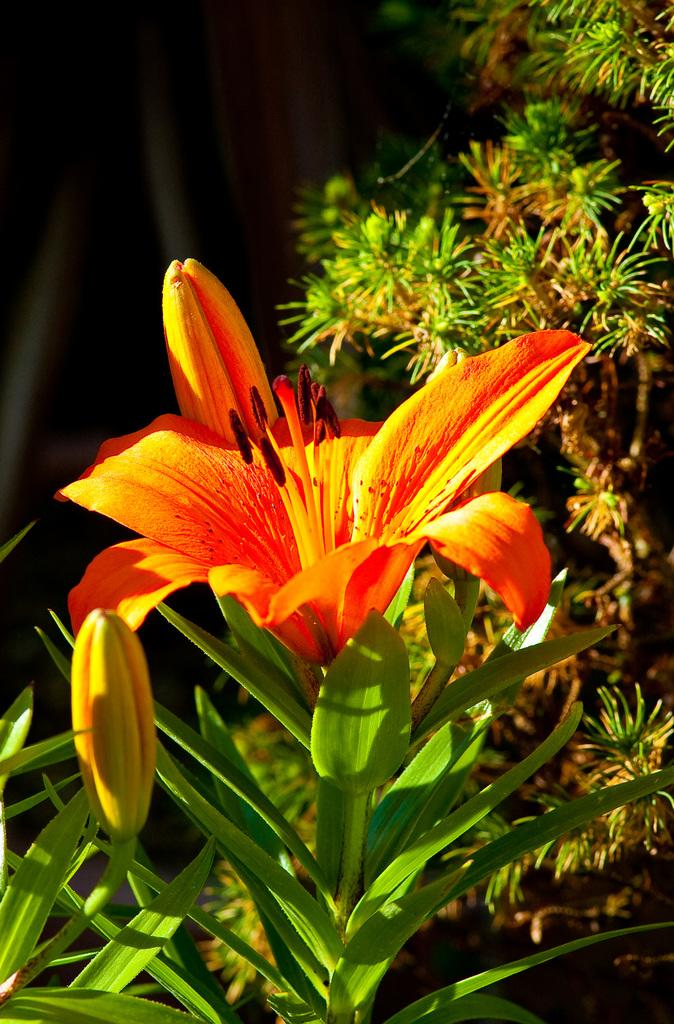What type of plant is featured in the image? There is a flower in the image. What stage of growth are the buds on the plant in? The buds on the plant are not yet fully bloomed. Are there any other plants visible in the image? Yes, there are other plants visible in the image. What is the color of the background in the image? The background of the image is dark. Can you see a scarecrow standing among the plants in the image? No, there is no scarecrow present in the image. How can you join the plants in the image to create a new plant species? The image does not provide information on how to join plants or create new species. 